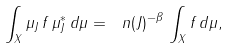Convert formula to latex. <formula><loc_0><loc_0><loc_500><loc_500>\int _ { X } \mu _ { J } \, f \, \mu _ { J } ^ { * } \, d \mu = \ n ( J ) ^ { - \beta } \, \int _ { X } f \, d \mu ,</formula> 